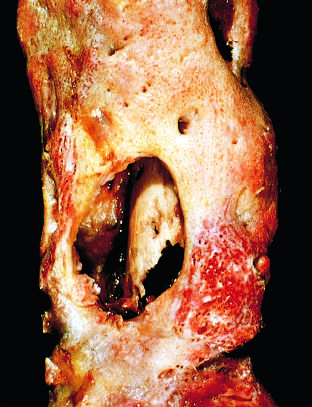does the drainage tract in the subperiosteal shell of viable new bone show the inner native necrotic cortex (sequestrum)?
Answer the question using a single word or phrase. Yes 